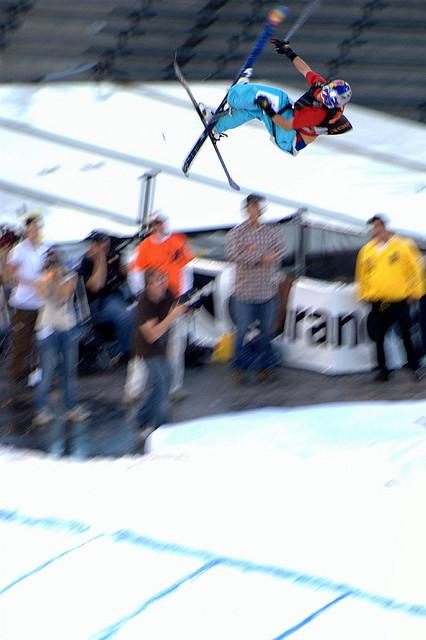What color is the jacket?
Concise answer only. Yellow. Does the person doing the jump in the photograph appear to be under control?
Be succinct. Yes. Is the picture blurry?
Write a very short answer. Yes. Are his skis crossed?
Give a very brief answer. Yes. 